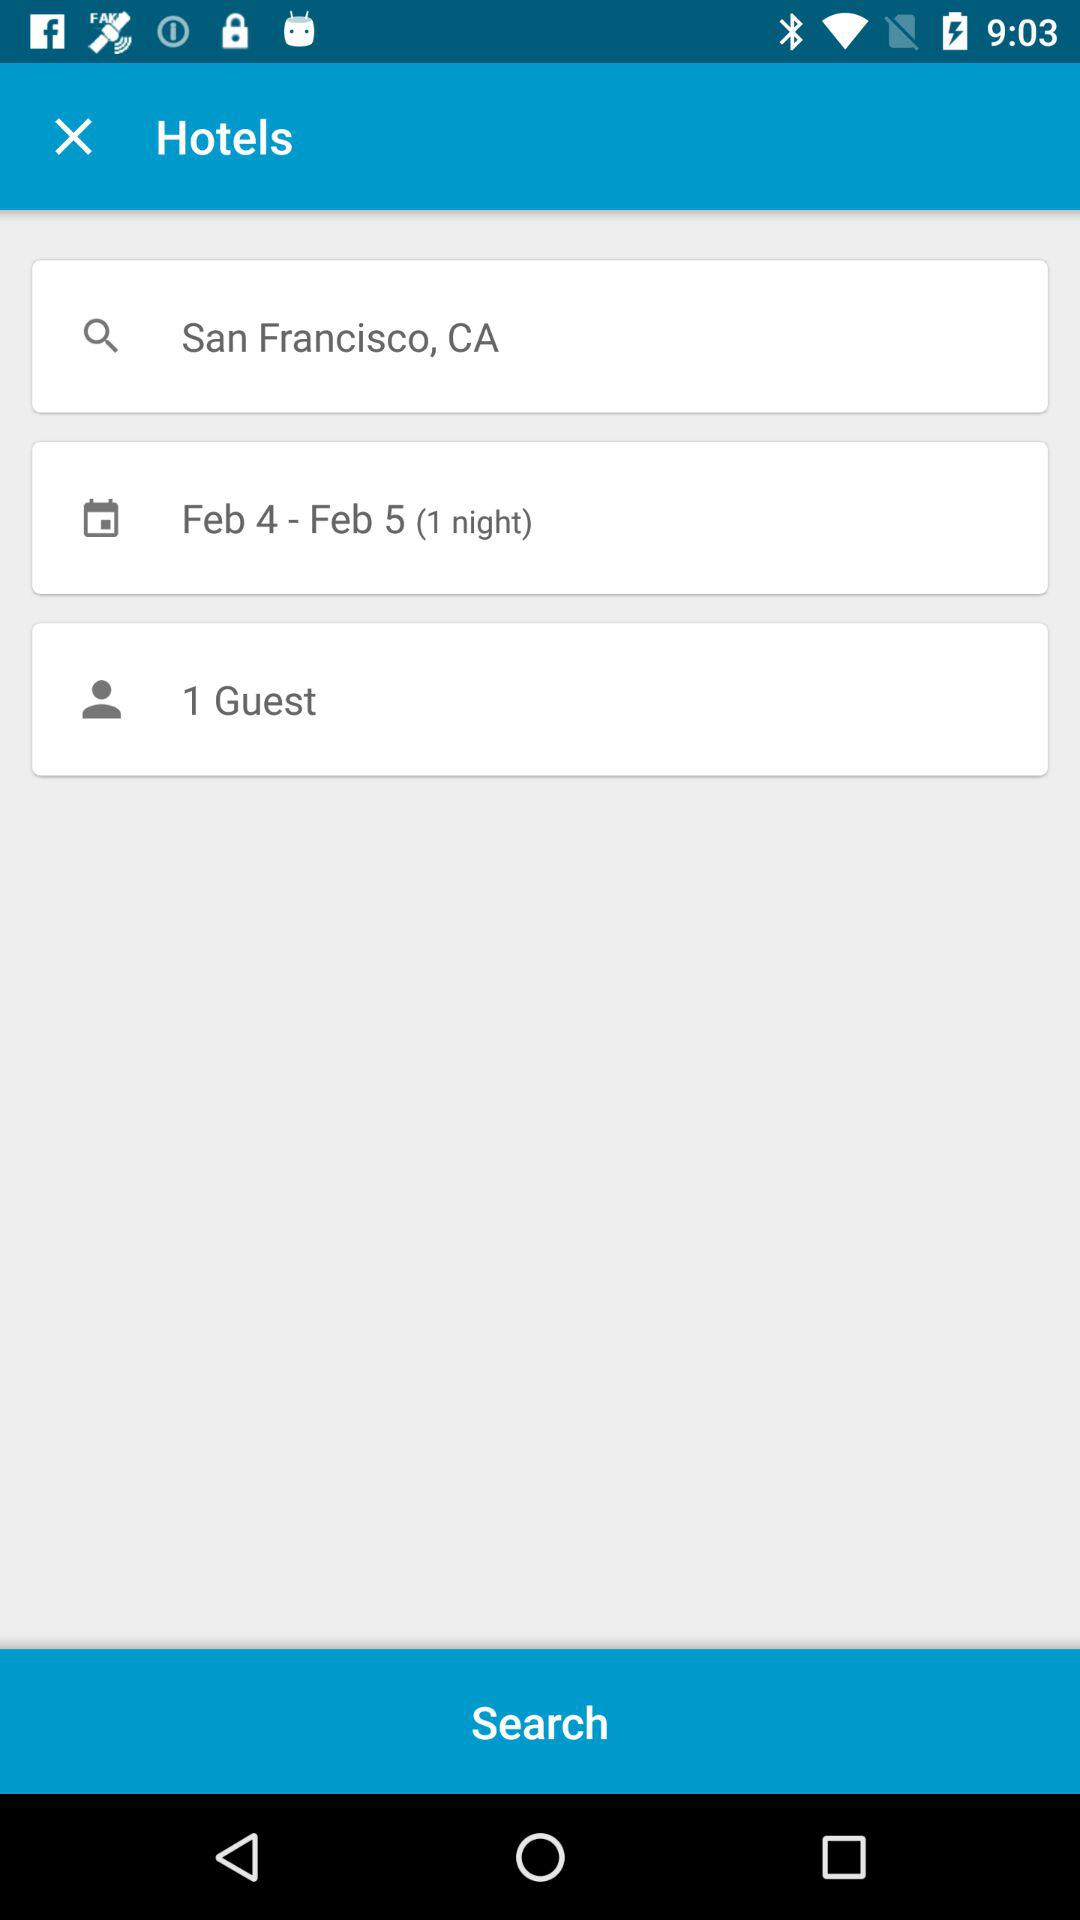How many guests are in the search?
Answer the question using a single word or phrase. 1 